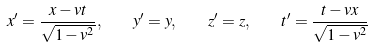<formula> <loc_0><loc_0><loc_500><loc_500>x ^ { \prime } = { \frac { x - v t } { \sqrt { 1 - v ^ { 2 } } } } , \quad y ^ { \prime } = y , \quad z ^ { \prime } = z , \quad t ^ { \prime } = { \frac { t - v x } { \sqrt { 1 - v ^ { 2 } } } }</formula> 